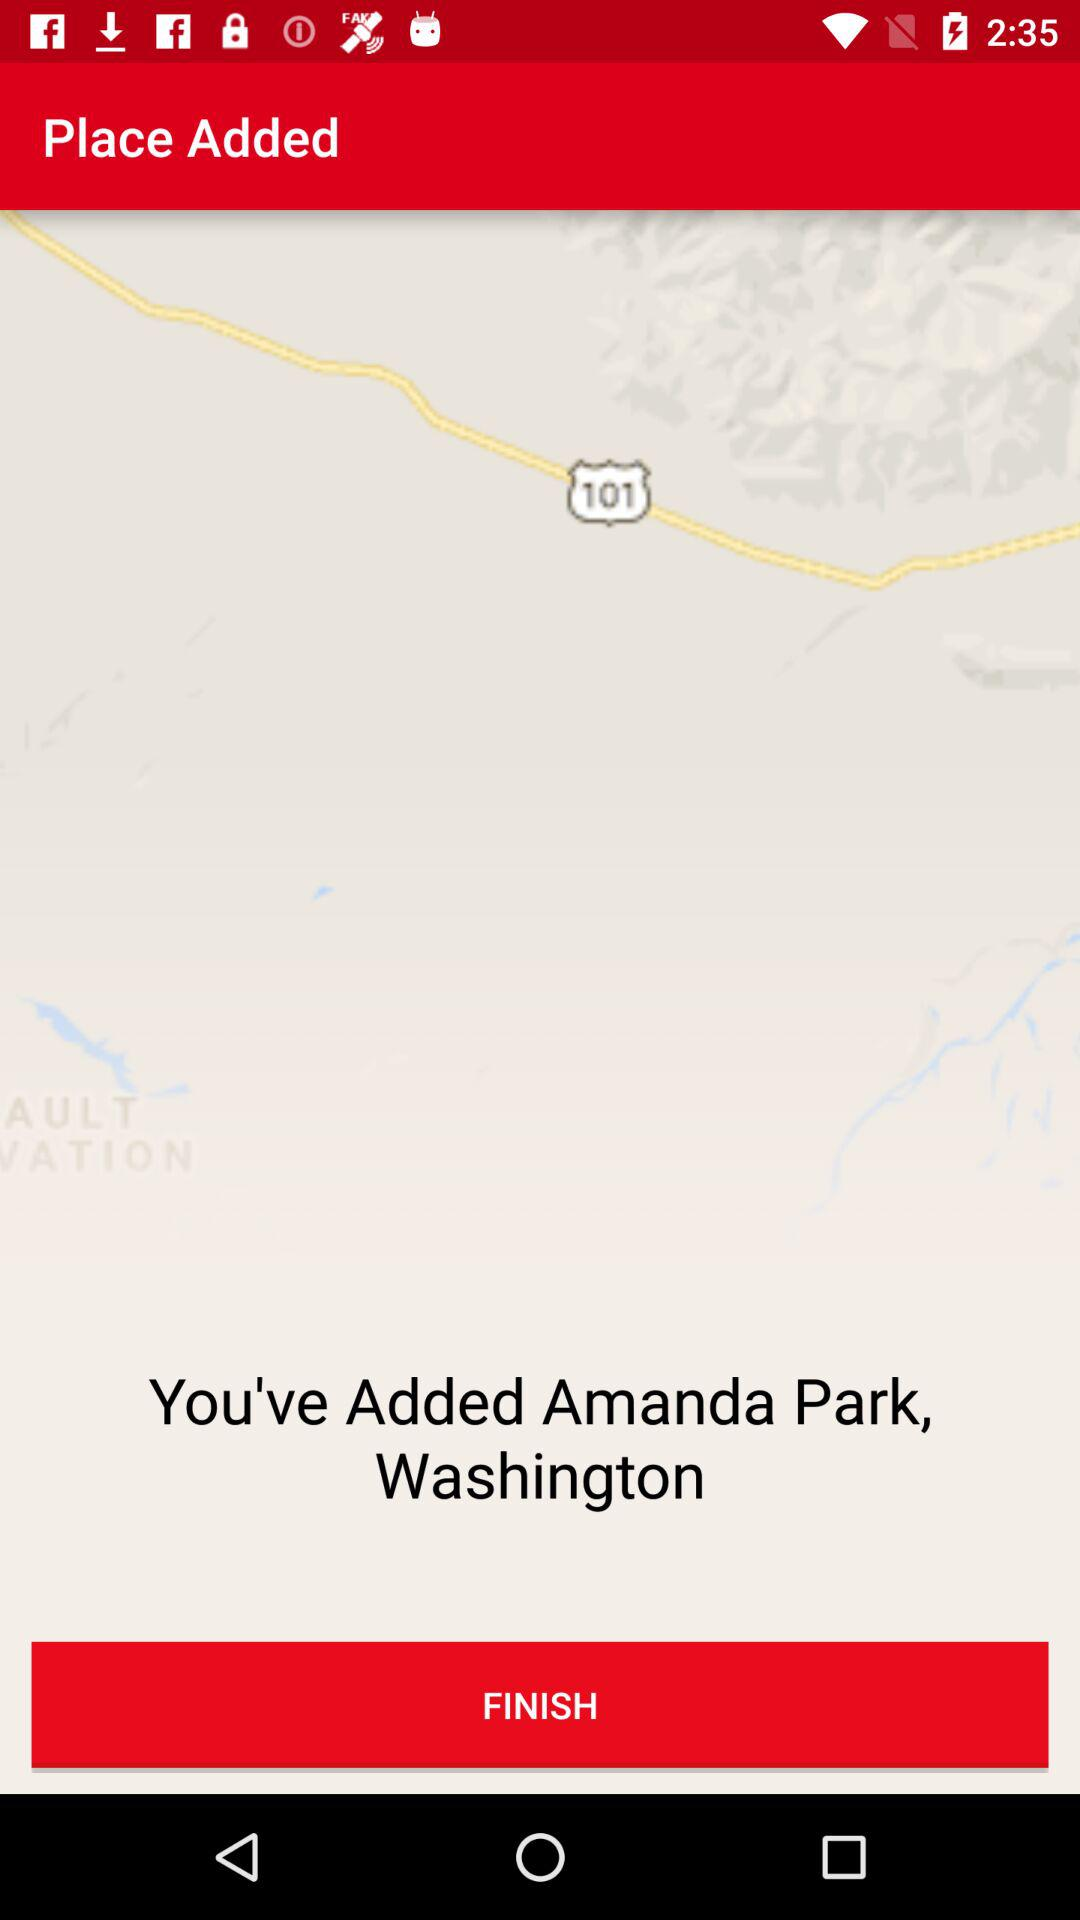What is the added location? The added location is Amanda Park, Washington. 